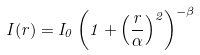Convert formula to latex. <formula><loc_0><loc_0><loc_500><loc_500>I ( r ) = I _ { 0 } \left ( 1 + \left ( \frac { r } { \alpha } \right ) ^ { 2 } \right ) ^ { - \beta }</formula> 